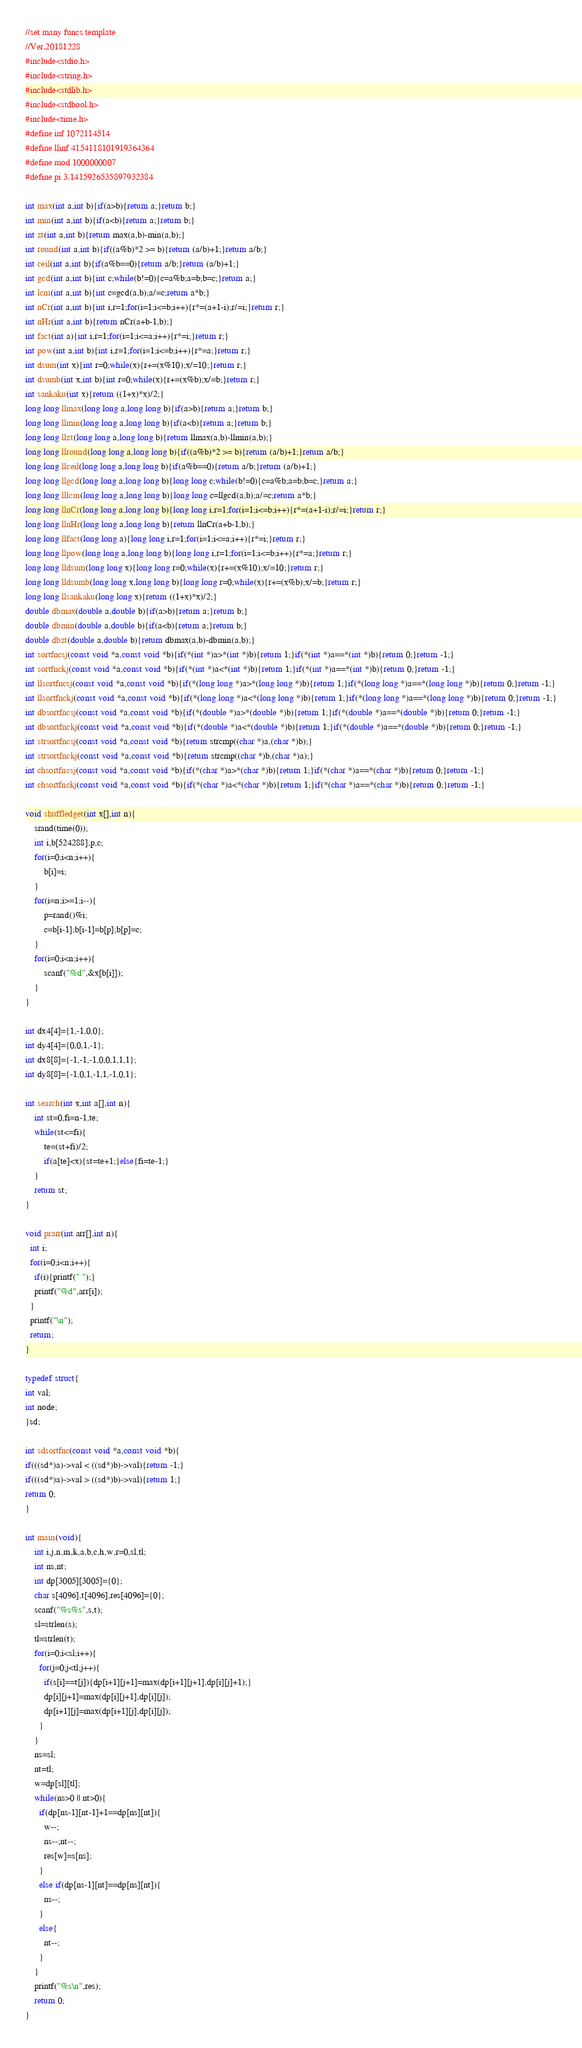<code> <loc_0><loc_0><loc_500><loc_500><_C_>//set many funcs template
//Ver.20181228
#include<stdio.h>
#include<string.h>
#include<stdlib.h>
#include<stdbool.h>
#include<time.h>
#define inf 1072114514
#define llinf 4154118101919364364
#define mod 1000000007
#define pi 3.1415926535897932384

int max(int a,int b){if(a>b){return a;}return b;}
int min(int a,int b){if(a<b){return a;}return b;}
int zt(int a,int b){return max(a,b)-min(a,b);}
int round(int a,int b){if((a%b)*2 >= b){return (a/b)+1;}return a/b;}
int ceil(int a,int b){if(a%b==0){return a/b;}return (a/b)+1;}
int gcd(int a,int b){int c;while(b!=0){c=a%b;a=b;b=c;}return a;}
int lcm(int a,int b){int c=gcd(a,b);a/=c;return a*b;}
int nCr(int a,int b){int i,r=1;for(i=1;i<=b;i++){r*=(a+1-i);r/=i;}return r;}
int nHr(int a,int b){return nCr(a+b-1,b);}
int fact(int a){int i,r=1;for(i=1;i<=a;i++){r*=i;}return r;}
int pow(int a,int b){int i,r=1;for(i=1;i<=b;i++){r*=a;}return r;}
int dsum(int x){int r=0;while(x){r+=(x%10);x/=10;}return r;}
int dsumb(int x,int b){int r=0;while(x){r+=(x%b);x/=b;}return r;}
int sankaku(int x){return ((1+x)*x)/2;}
long long llmax(long long a,long long b){if(a>b){return a;}return b;}
long long llmin(long long a,long long b){if(a<b){return a;}return b;}
long long llzt(long long a,long long b){return llmax(a,b)-llmin(a,b);}
long long llround(long long a,long long b){if((a%b)*2 >= b){return (a/b)+1;}return a/b;}
long long llceil(long long a,long long b){if(a%b==0){return a/b;}return (a/b)+1;}
long long llgcd(long long a,long long b){long long c;while(b!=0){c=a%b;a=b;b=c;}return a;}
long long lllcm(long long a,long long b){long long c=llgcd(a,b);a/=c;return a*b;}
long long llnCr(long long a,long long b){long long i,r=1;for(i=1;i<=b;i++){r*=(a+1-i);r/=i;}return r;}
long long llnHr(long long a,long long b){return llnCr(a+b-1,b);}
long long llfact(long long a){long long i,r=1;for(i=1;i<=a;i++){r*=i;}return r;}
long long llpow(long long a,long long b){long long i,r=1;for(i=1;i<=b;i++){r*=a;}return r;}
long long lldsum(long long x){long long r=0;while(x){r+=(x%10);x/=10;}return r;}
long long lldsumb(long long x,long long b){long long r=0;while(x){r+=(x%b);x/=b;}return r;}
long long llsankaku(long long x){return ((1+x)*x)/2;}
double dbmax(double a,double b){if(a>b){return a;}return b;}
double dbmin(double a,double b){if(a<b){return a;}return b;}
double dbzt(double a,double b){return dbmax(a,b)-dbmin(a,b);}
int sortfncsj(const void *a,const void *b){if(*(int *)a>*(int *)b){return 1;}if(*(int *)a==*(int *)b){return 0;}return -1;}
int sortfnckj(const void *a,const void *b){if(*(int *)a<*(int *)b){return 1;}if(*(int *)a==*(int *)b){return 0;}return -1;}
int llsortfncsj(const void *a,const void *b){if(*(long long *)a>*(long long *)b){return 1;}if(*(long long *)a==*(long long *)b){return 0;}return -1;}
int llsortfnckj(const void *a,const void *b){if(*(long long *)a<*(long long *)b){return 1;}if(*(long long *)a==*(long long *)b){return 0;}return -1;}
int dbsortfncsj(const void *a,const void *b){if(*(double *)a>*(double *)b){return 1;}if(*(double *)a==*(double *)b){return 0;}return -1;}
int dbsortfnckj(const void *a,const void *b){if(*(double *)a<*(double *)b){return 1;}if(*(double *)a==*(double *)b){return 0;}return -1;}
int strsortfncsj(const void *a,const void *b){return strcmp((char *)a,(char *)b);}
int strsortfnckj(const void *a,const void *b){return strcmp((char *)b,(char *)a);}
int chsortfncsj(const void *a,const void *b){if(*(char *)a>*(char *)b){return 1;}if(*(char *)a==*(char *)b){return 0;}return -1;}
int chsortfnckj(const void *a,const void *b){if(*(char *)a<*(char *)b){return 1;}if(*(char *)a==*(char *)b){return 0;}return -1;}

void shuffledget(int x[],int n){
    srand(time(0));
    int i,b[524288],p,c;
    for(i=0;i<n;i++){
        b[i]=i;
    }
    for(i=n;i>=1;i--){
        p=rand()%i;
        c=b[i-1];b[i-1]=b[p];b[p]=c;
    }
    for(i=0;i<n;i++){
        scanf("%d",&x[b[i]]);
    }
}

int dx4[4]={1,-1,0,0};
int dy4[4]={0,0,1,-1};
int dx8[8]={-1,-1,-1,0,0,1,1,1};
int dy8[8]={-1,0,1,-1,1,-1,0,1};

int search(int x,int a[],int n){
    int st=0,fi=n-1,te;
    while(st<=fi){
        te=(st+fi)/2;
        if(a[te]<x){st=te+1;}else{fi=te-1;}
    }
    return st;
}

void prarr(int arr[],int n){
  int i;
  for(i=0;i<n;i++){
    if(i){printf(" ");}
    printf("%d",arr[i]);
  }
  printf("\n");
  return;
}

typedef struct{
int val;
int node;
}sd;

int sdsortfnc(const void *a,const void *b){
if(((sd*)a)->val < ((sd*)b)->val){return -1;}
if(((sd*)a)->val > ((sd*)b)->val){return 1;}
return 0;
}

int main(void){
    int i,j,n,m,k,a,b,c,h,w,r=0,sl,tl;
    int ns,nt;
    int dp[3005][3005]={0};
    char s[4096],t[4096],res[4096]={0};
    scanf("%s%s",s,t);
    sl=strlen(s);
    tl=strlen(t);
    for(i=0;i<sl;i++){
      for(j=0;j<tl;j++){
        if(s[i]==t[j]){dp[i+1][j+1]=max(dp[i+1][j+1],dp[i][j]+1);}
        dp[i][j+1]=max(dp[i][j+1],dp[i][j]);
        dp[i+1][j]=max(dp[i+1][j],dp[i][j]);          
      }
    }
    ns=sl;
    nt=tl;
    w=dp[sl][tl];
    while(ns>0 || nt>0){
      if(dp[ns-1][nt-1]+1==dp[ns][nt]){
        w--;
        ns--;nt--;
        res[w]=s[ns];
      }
      else if(dp[ns-1][nt]==dp[ns][nt]){
        ns--;
      }
      else{
        nt--;
      }
    }
    printf("%s\n",res);
    return 0;
}
</code> 